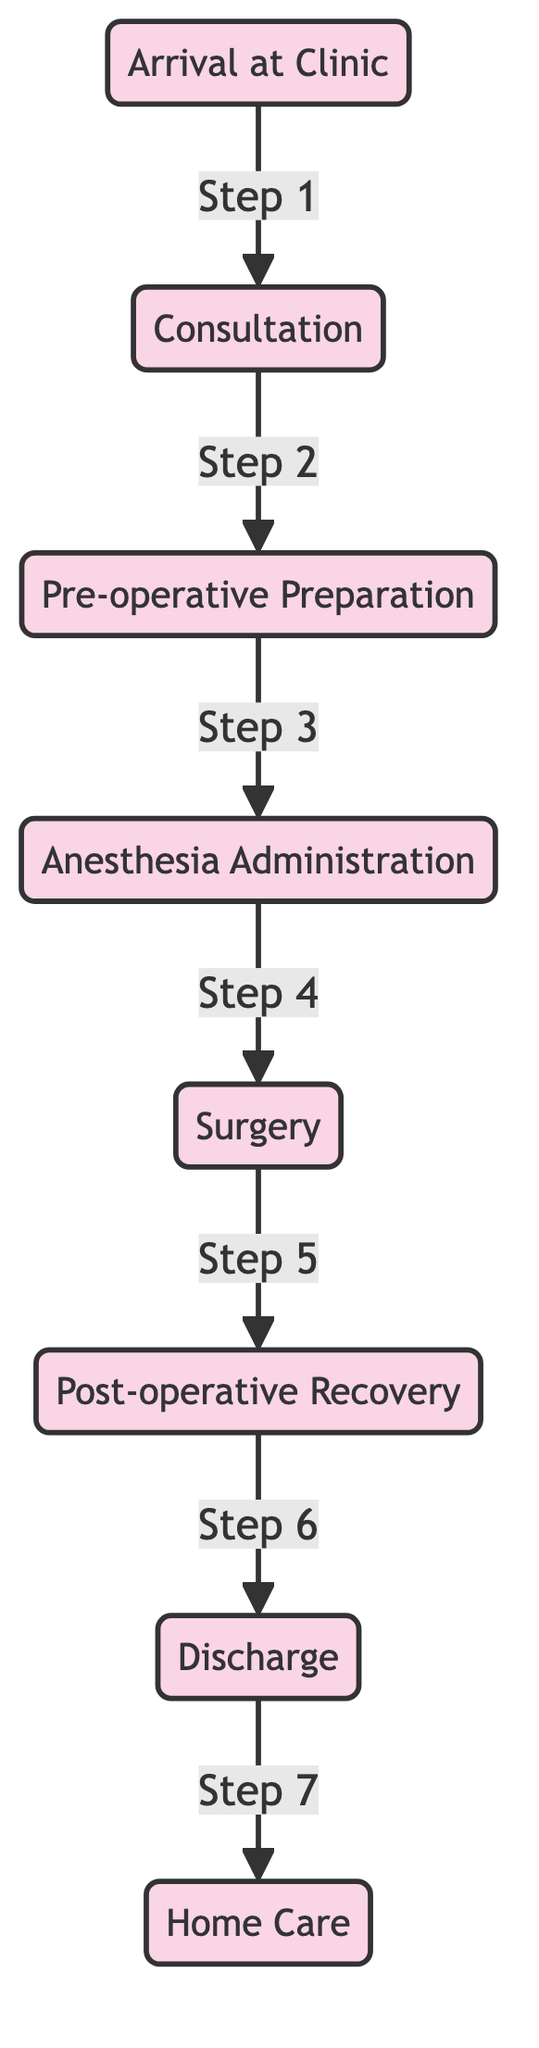What is the first step in the surgery process? The diagram indicates that the first step is "Arrival at Clinic", which is the entry point of the flowchart.
Answer: Arrival at Clinic How many main stages are there in the surgery process? By counting the nodes in the diagram, we find that there are a total of seven stages from "Arrival at Clinic" to "Home Care".
Answer: Seven Which step follows "Anesthesia Administration"? Looking at the flow, the step that comes after "Anesthesia Administration" is "Surgery", as indicated by the arrow leading from one to the other.
Answer: Surgery What is the last stage before a pet returns home? The final stage listed in the diagram before returning home is "Home Care", which is the last node connected to "Discharge".
Answer: Home Care What two steps are directly connected to the "Recovery" stage? The diagram shows that "Recovery" is directly preceded by "Surgery" and directly followed by "Discharge".
Answer: Surgery and Discharge Which stage is labeled as step 4? According to the flowchart, "Surgery" is labeled as step 4, as indicated by the associated step number leading to that node.
Answer: Surgery What is the relationship between "Pre-operative Preparation" and "Anesthesia Administration"? The relationship is sequential; "Pre-operative Preparation" directly leads to "Anesthesia Administration" in the order of operations.
Answer: Sequential What is the process that occurs after "Post-operative Recovery"? The process that follows "Post-operative Recovery" is "Discharge", which indicates the transition from recovery to going home.
Answer: Discharge 